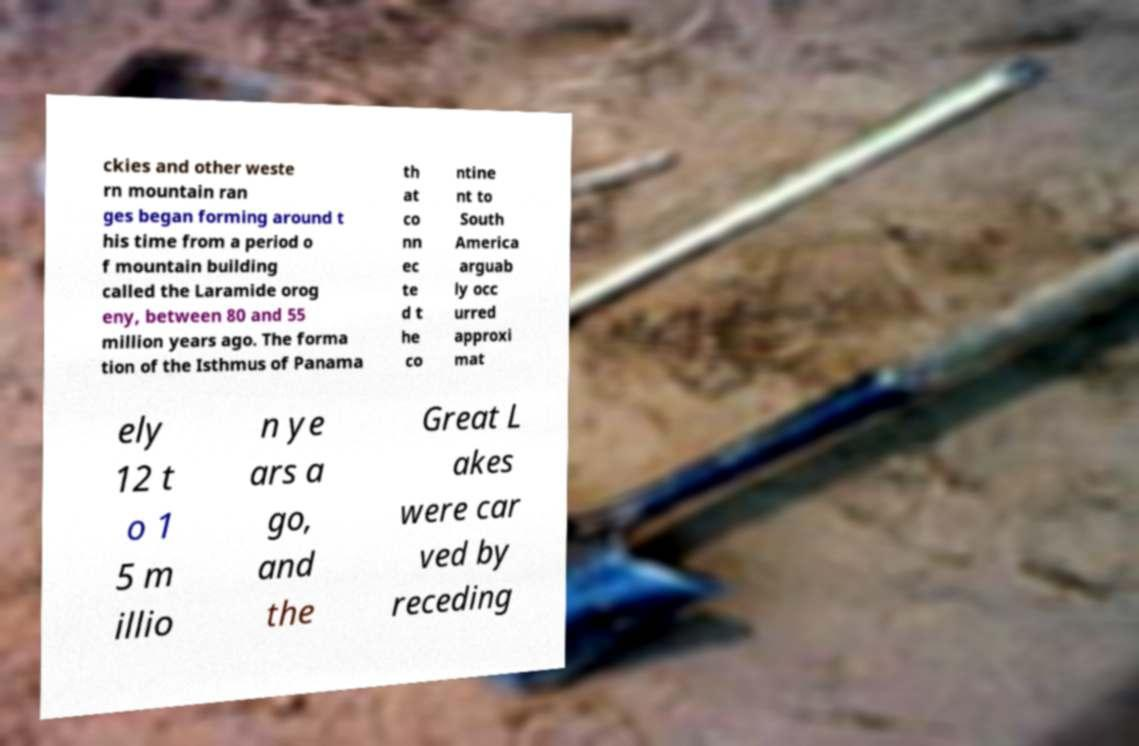Could you extract and type out the text from this image? ckies and other weste rn mountain ran ges began forming around t his time from a period o f mountain building called the Laramide orog eny, between 80 and 55 million years ago. The forma tion of the Isthmus of Panama th at co nn ec te d t he co ntine nt to South America arguab ly occ urred approxi mat ely 12 t o 1 5 m illio n ye ars a go, and the Great L akes were car ved by receding 